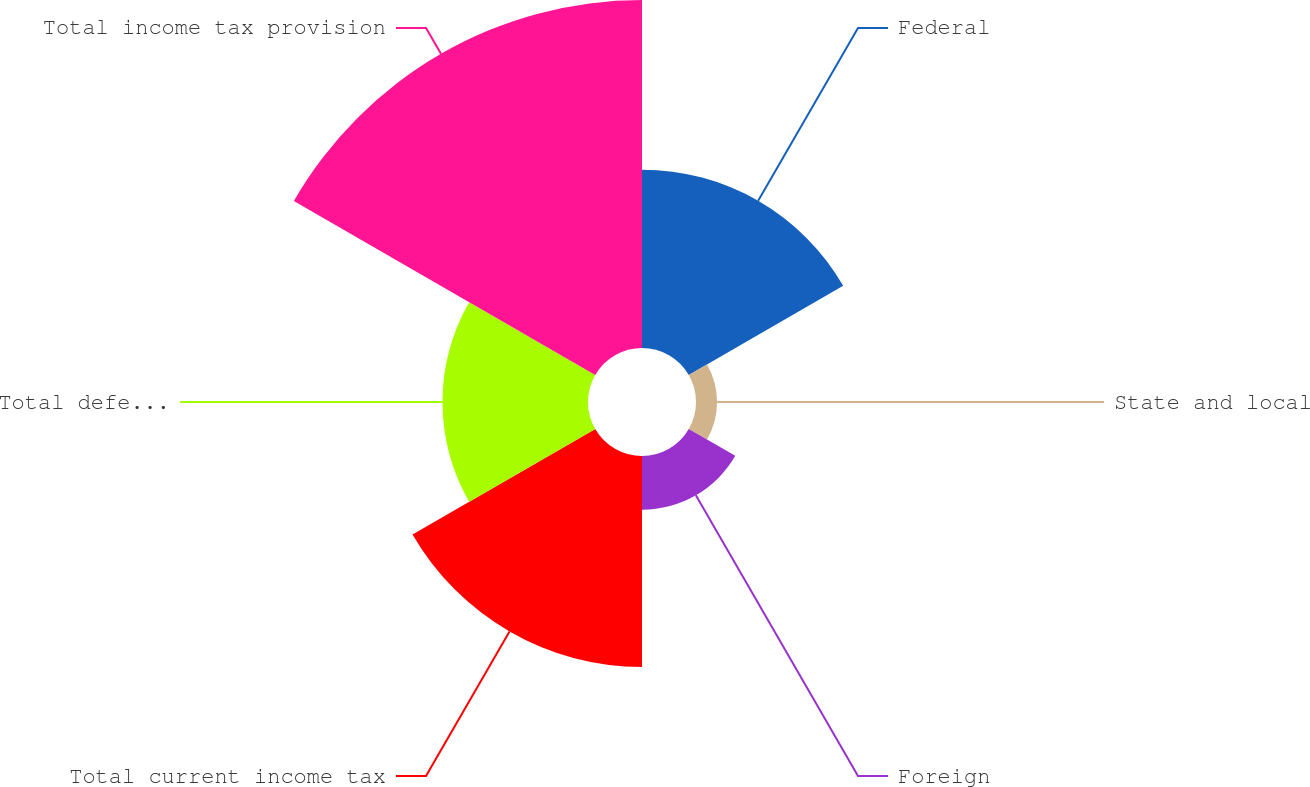<chart> <loc_0><loc_0><loc_500><loc_500><pie_chart><fcel>Federal<fcel>State and local<fcel>Foreign<fcel>Total current income tax<fcel>Total deferred income tax<fcel>Total income tax provision<nl><fcel>18.62%<fcel>2.2%<fcel>5.61%<fcel>22.03%<fcel>15.2%<fcel>36.34%<nl></chart> 